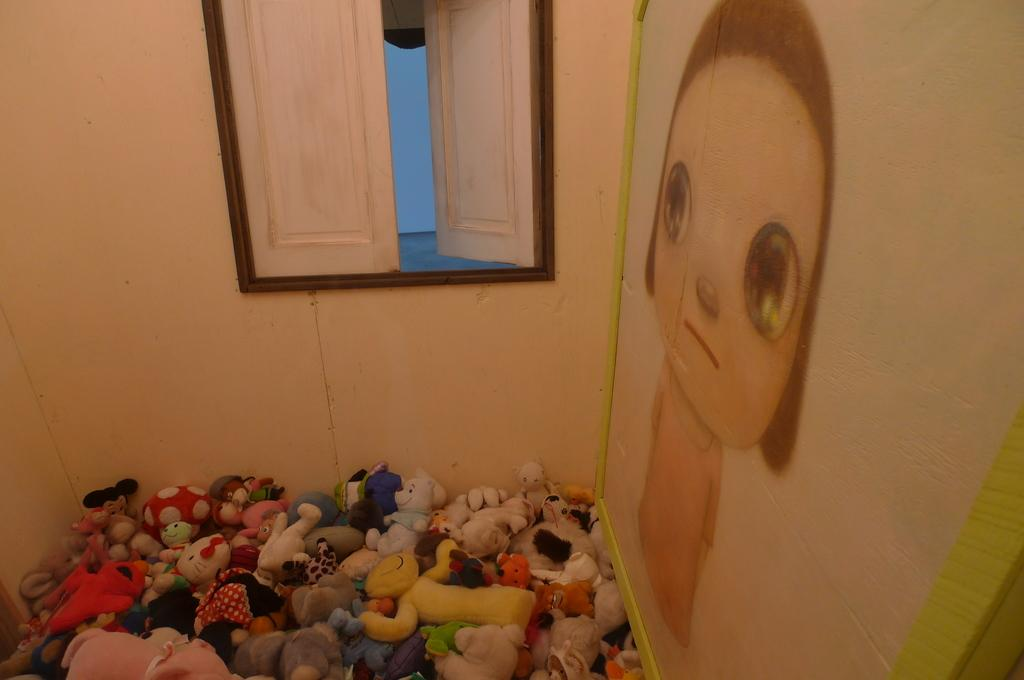What type of opening is present in the image? There is a window with doors in the image. What type of structure is visible in the image? There is a wall in the image. What type of decorative item is present in the image? There is a photo frame in the image. What type of objects are visible at the bottom of the image? Toys are visible at the bottom of the image. What type of wound can be seen on the toys in the image? There are no wounds visible on the toys in the image. What type of pets are present in the image? There are no pets present in the image. 